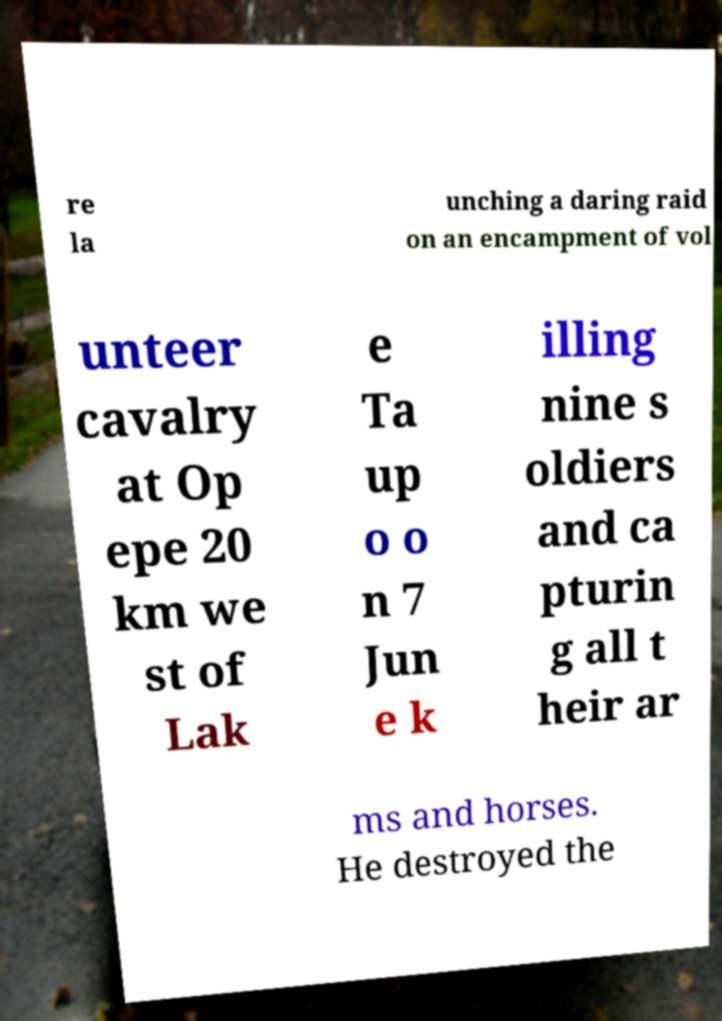Could you assist in decoding the text presented in this image and type it out clearly? re la unching a daring raid on an encampment of vol unteer cavalry at Op epe 20 km we st of Lak e Ta up o o n 7 Jun e k illing nine s oldiers and ca pturin g all t heir ar ms and horses. He destroyed the 